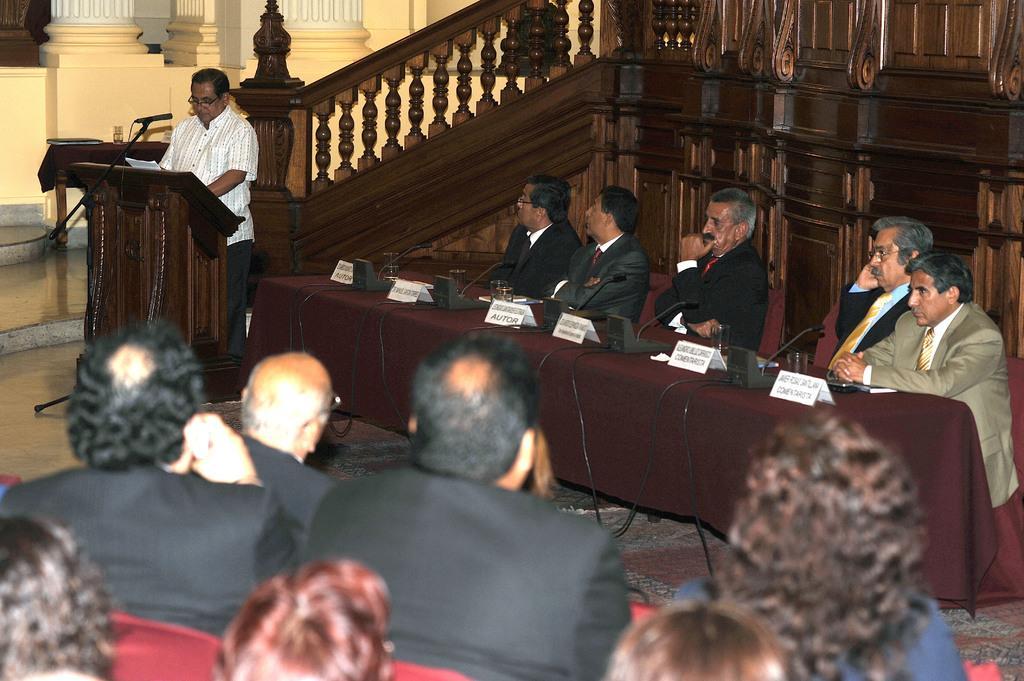Describe this image in one or two sentences. On the left side there is a man standing in front of the podium. On the right side few men are sitting on the chairs and looking at this man. In front of these people there is a table which is covered with a cloth. On this table few name boards, glasses, microphones and some other objects are placed. At the bottom few people are sitting on the chairs facing towards the back side. At the top of the image there are few pillars and also there is a hand railing. 